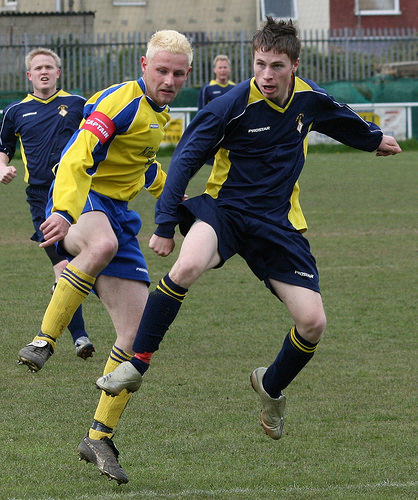<image>
Is there a man behind the man? No. The man is not behind the man. From this viewpoint, the man appears to be positioned elsewhere in the scene. 